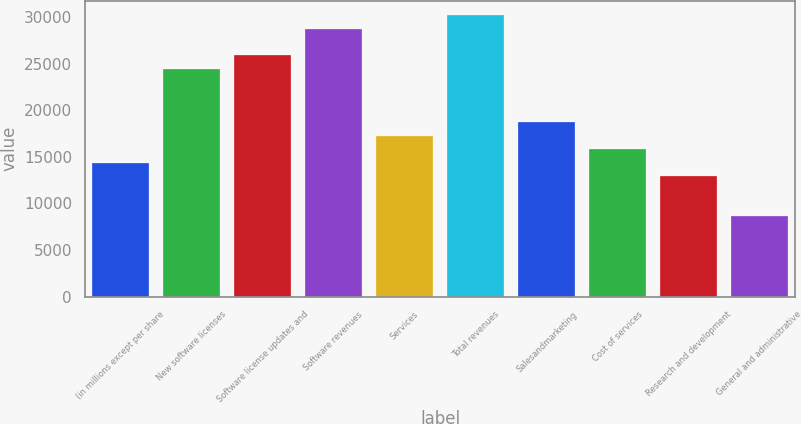<chart> <loc_0><loc_0><loc_500><loc_500><bar_chart><fcel>(in millions except per share<fcel>New software licenses<fcel>Software license updates and<fcel>Software revenues<fcel>Services<fcel>Total revenues<fcel>Salesandmarketing<fcel>Cost of services<fcel>Research and development<fcel>General and administrative<nl><fcel>14380<fcel>24445.6<fcel>25883.6<fcel>28759.4<fcel>17255.9<fcel>30197.4<fcel>18693.9<fcel>15818<fcel>12942.1<fcel>8628.28<nl></chart> 